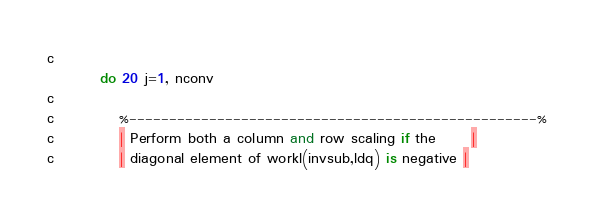<code> <loc_0><loc_0><loc_500><loc_500><_FORTRAN_>c
         do 20 j=1, nconv
c
c           %---------------------------------------------------%
c           | Perform both a column and row scaling if the      |
c           | diagonal element of workl(invsub,ldq) is negative |</code> 